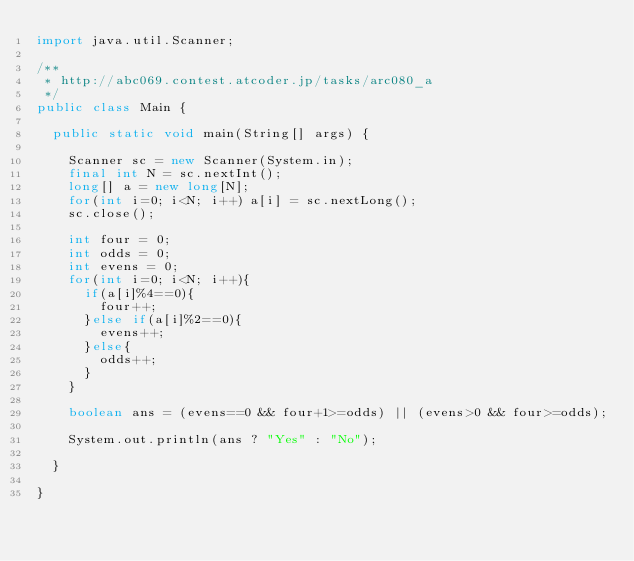Convert code to text. <code><loc_0><loc_0><loc_500><loc_500><_Java_>import java.util.Scanner;

/**
 * http://abc069.contest.atcoder.jp/tasks/arc080_a
 */
public class Main {

	public static void main(String[] args) {
		
		Scanner sc = new Scanner(System.in);
		final int N = sc.nextInt();
		long[] a = new long[N];
		for(int i=0; i<N; i++) a[i] = sc.nextLong();
		sc.close();
		
		int four = 0;
		int odds = 0;
		int evens = 0;
		for(int i=0; i<N; i++){
			if(a[i]%4==0){
				four++;
			}else if(a[i]%2==0){
				evens++;
			}else{
				odds++;
			}
		}
		
		boolean ans = (evens==0 && four+1>=odds) || (evens>0 && four>=odds);
		
		System.out.println(ans ? "Yes" : "No");

	}

}</code> 